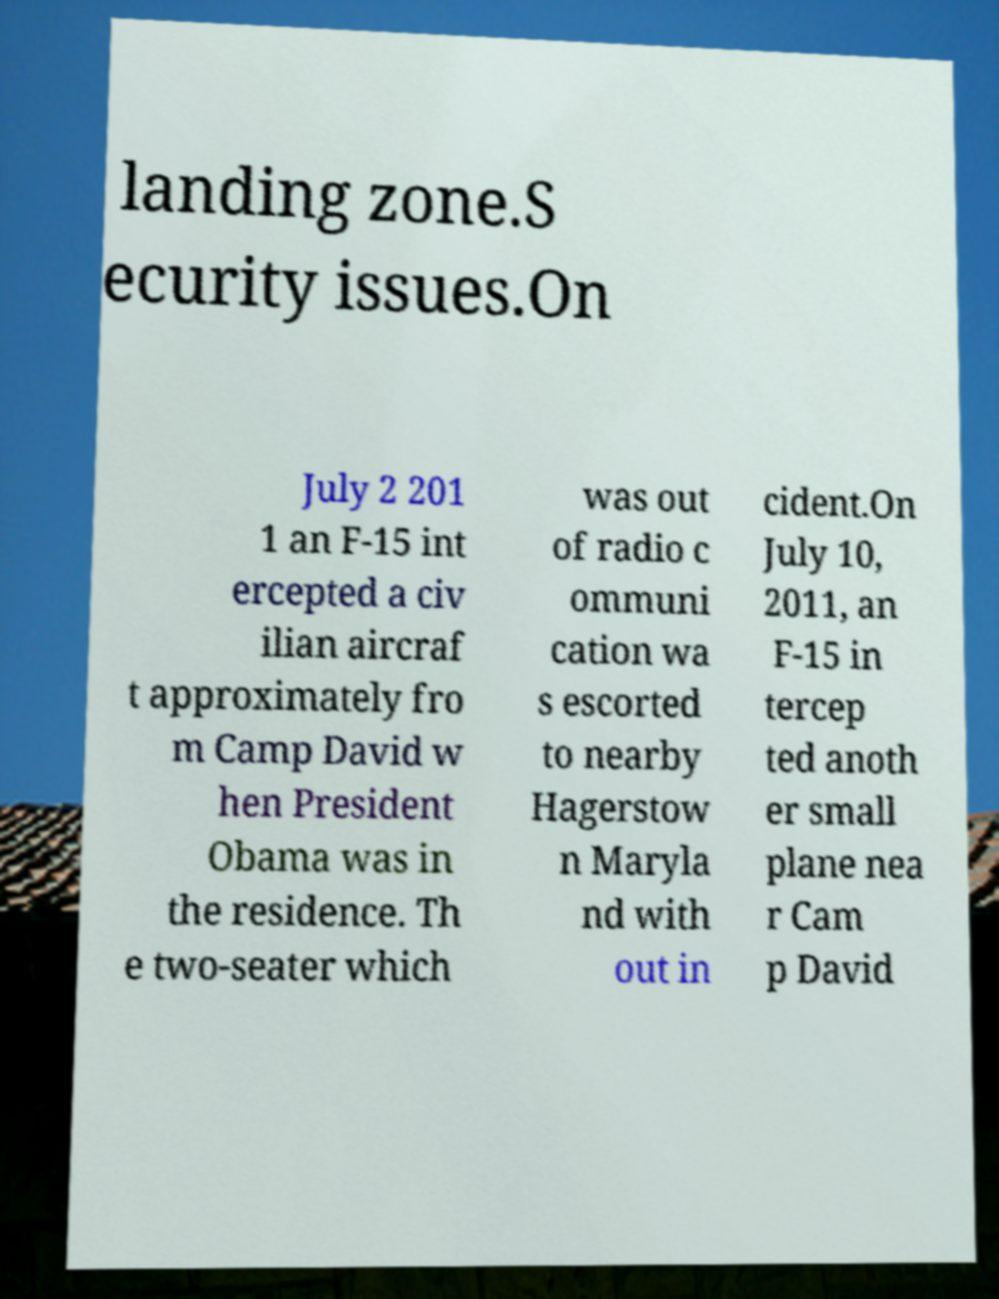Could you assist in decoding the text presented in this image and type it out clearly? landing zone.S ecurity issues.On July 2 201 1 an F-15 int ercepted a civ ilian aircraf t approximately fro m Camp David w hen President Obama was in the residence. Th e two-seater which was out of radio c ommuni cation wa s escorted to nearby Hagerstow n Maryla nd with out in cident.On July 10, 2011, an F-15 in tercep ted anoth er small plane nea r Cam p David 